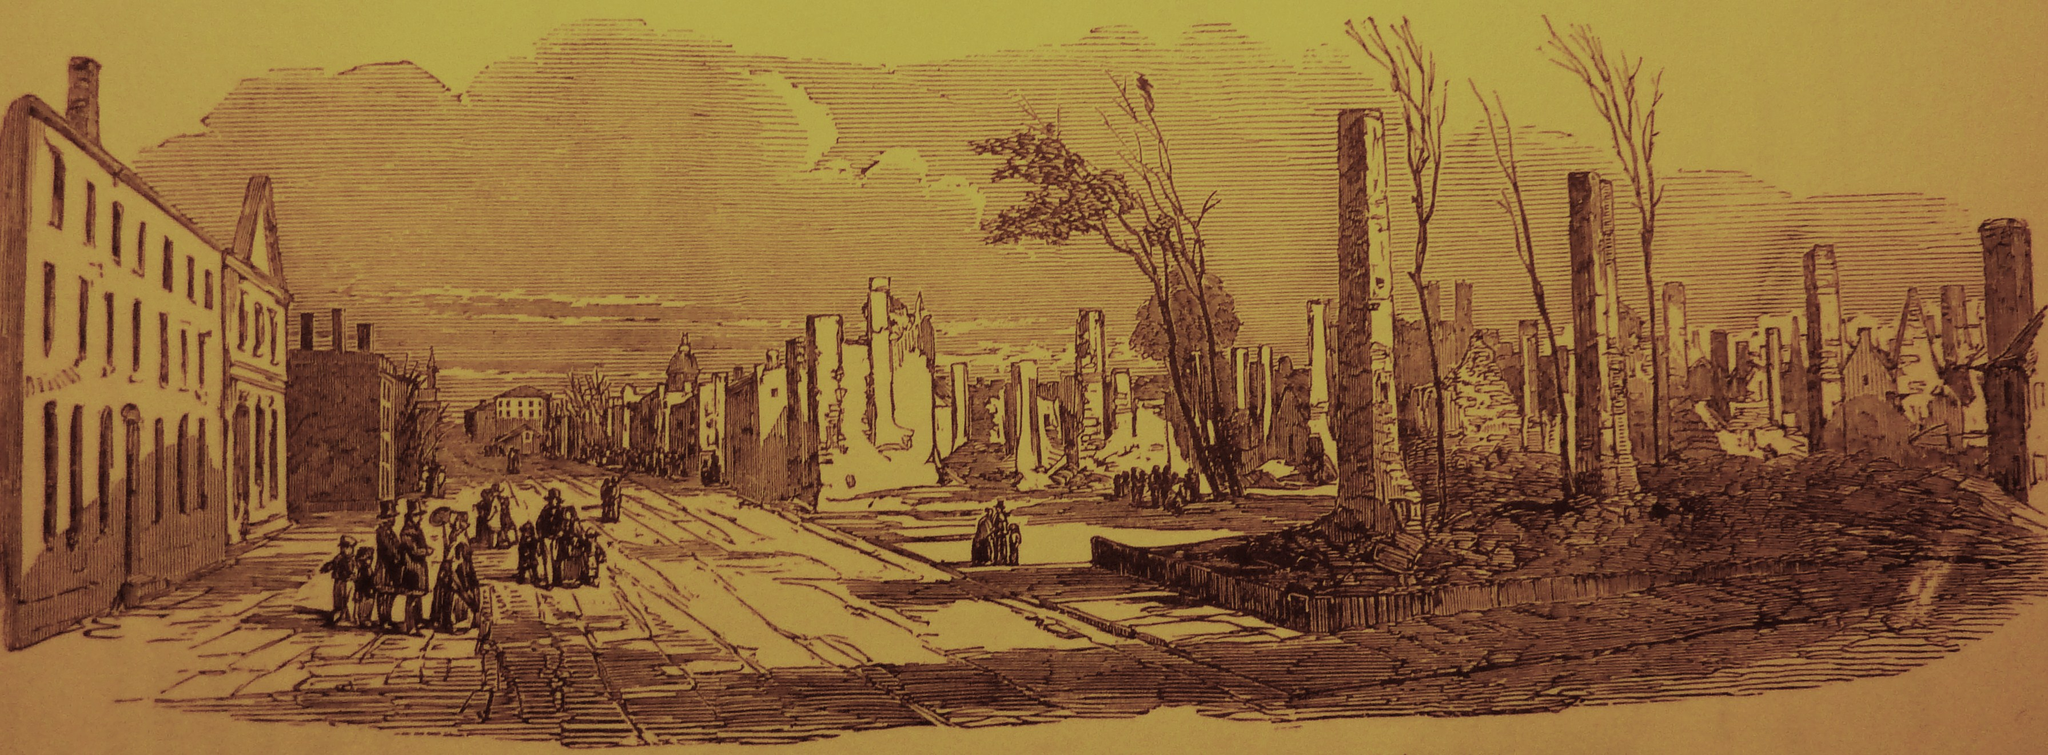In one or two sentences, can you explain what this image depicts? In this image I can see it is a painting, there are buildings, trees. On the left side there are few people at the top it is the sky. 